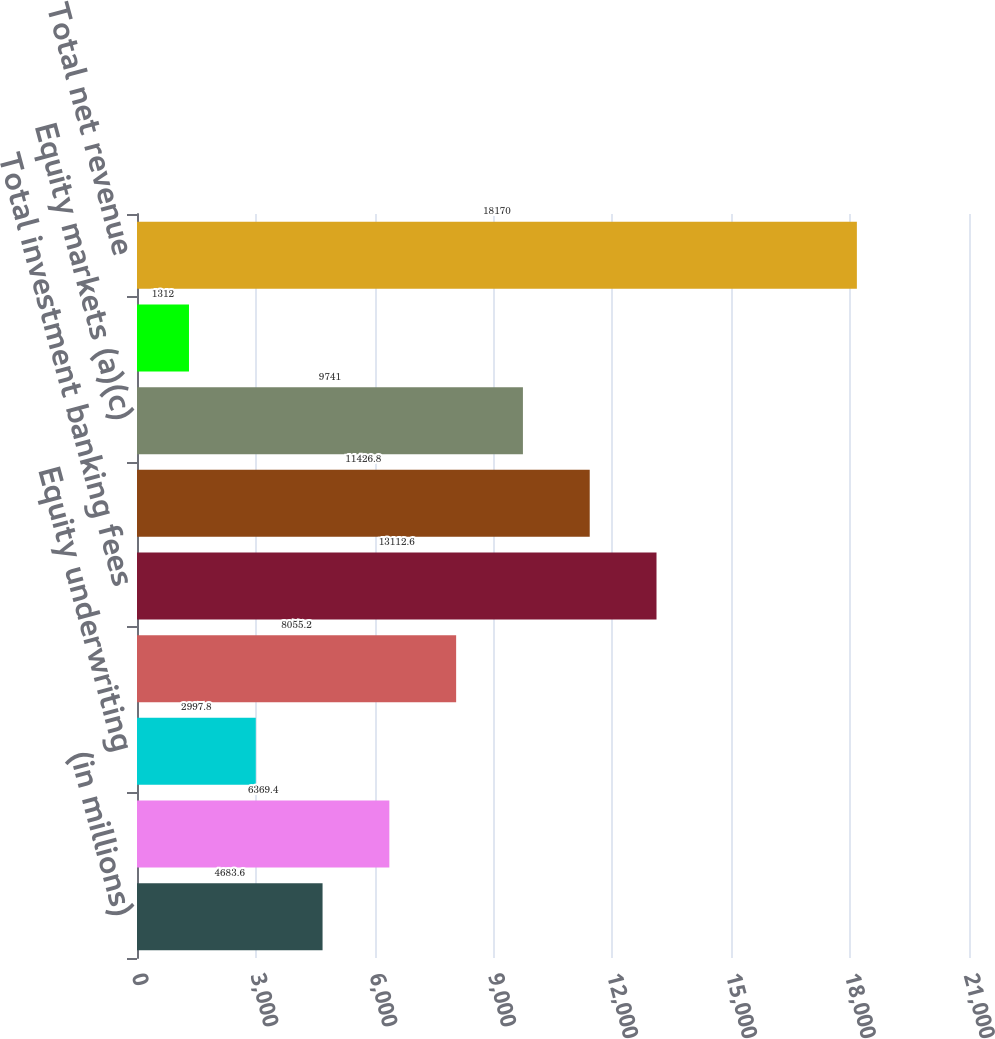Convert chart. <chart><loc_0><loc_0><loc_500><loc_500><bar_chart><fcel>(in millions)<fcel>Advisory<fcel>Equity underwriting<fcel>Debt underwriting<fcel>Total investment banking fees<fcel>Fixed income markets (a)(b)<fcel>Equity markets (a)(c)<fcel>Credit portfolio (a)(d)<fcel>Total net revenue<nl><fcel>4683.6<fcel>6369.4<fcel>2997.8<fcel>8055.2<fcel>13112.6<fcel>11426.8<fcel>9741<fcel>1312<fcel>18170<nl></chart> 